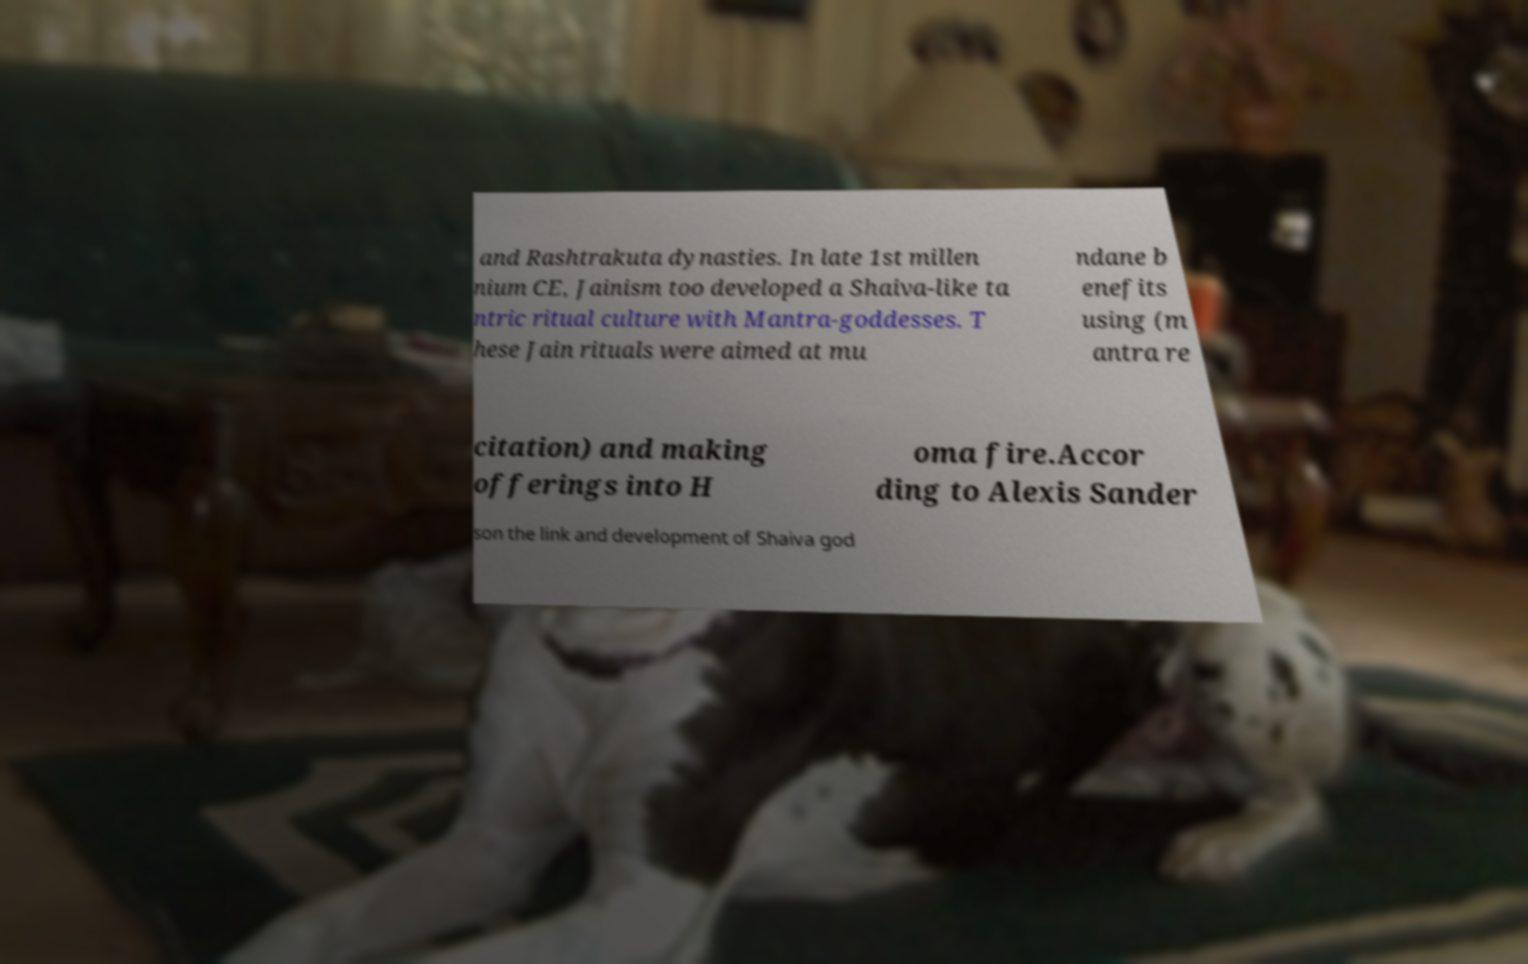Could you assist in decoding the text presented in this image and type it out clearly? and Rashtrakuta dynasties. In late 1st millen nium CE, Jainism too developed a Shaiva-like ta ntric ritual culture with Mantra-goddesses. T hese Jain rituals were aimed at mu ndane b enefits using (m antra re citation) and making offerings into H oma fire.Accor ding to Alexis Sander son the link and development of Shaiva god 